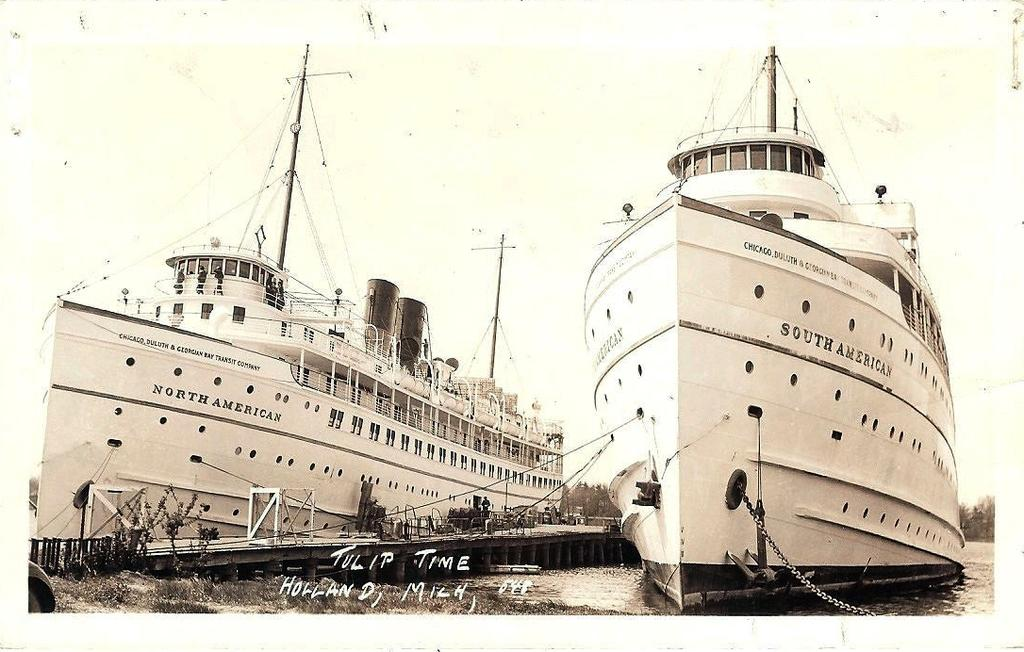<image>
Describe the image concisely. Two large white ships that read SOUTH AMERICA on their side. 